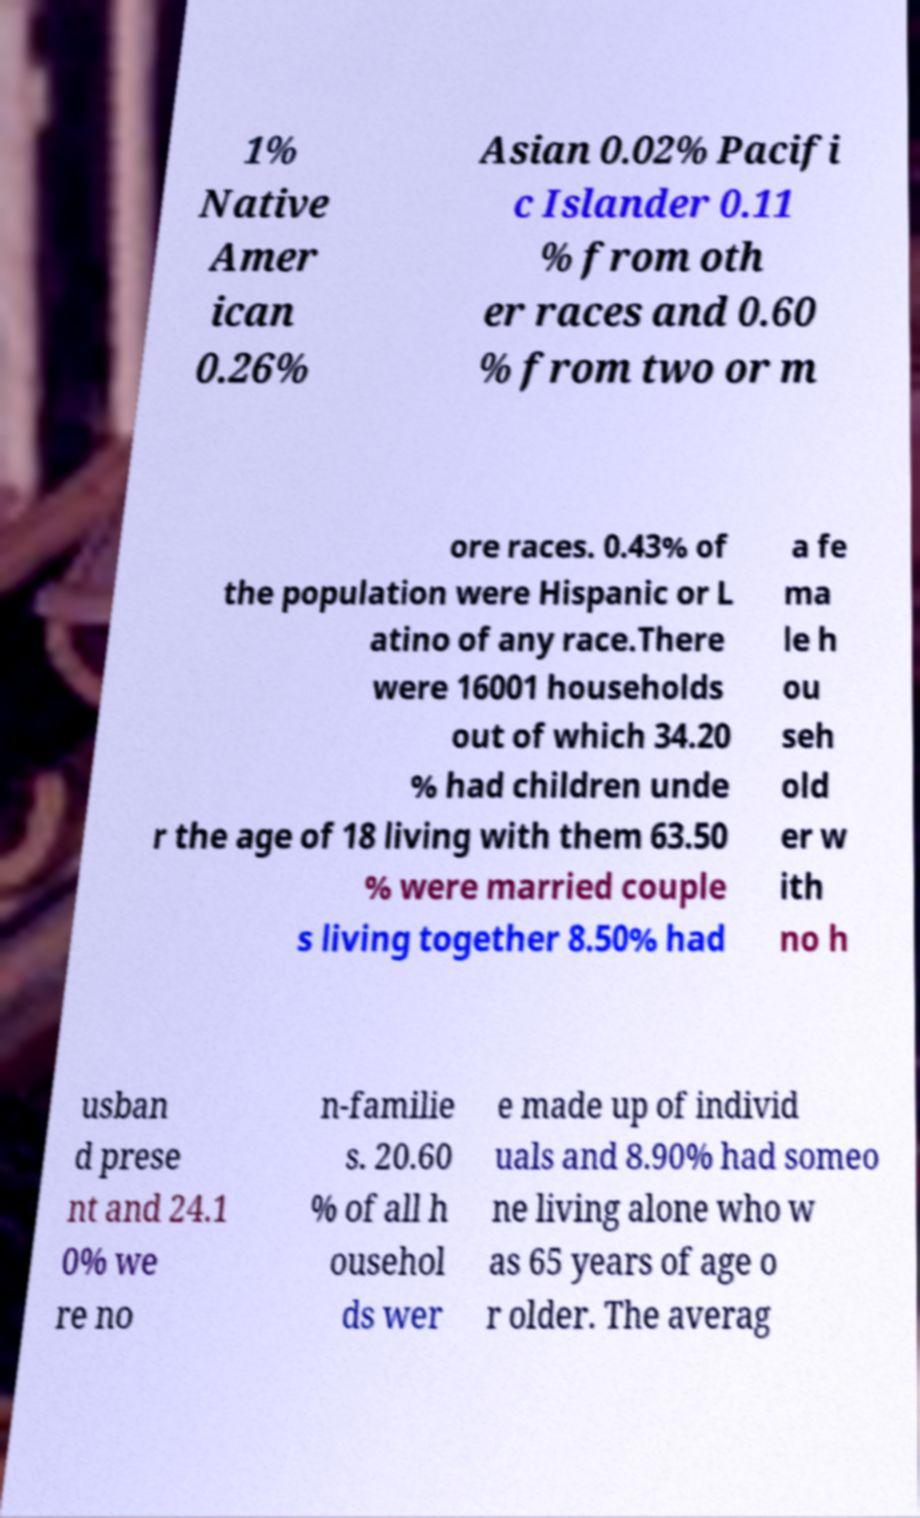For documentation purposes, I need the text within this image transcribed. Could you provide that? 1% Native Amer ican 0.26% Asian 0.02% Pacifi c Islander 0.11 % from oth er races and 0.60 % from two or m ore races. 0.43% of the population were Hispanic or L atino of any race.There were 16001 households out of which 34.20 % had children unde r the age of 18 living with them 63.50 % were married couple s living together 8.50% had a fe ma le h ou seh old er w ith no h usban d prese nt and 24.1 0% we re no n-familie s. 20.60 % of all h ousehol ds wer e made up of individ uals and 8.90% had someo ne living alone who w as 65 years of age o r older. The averag 